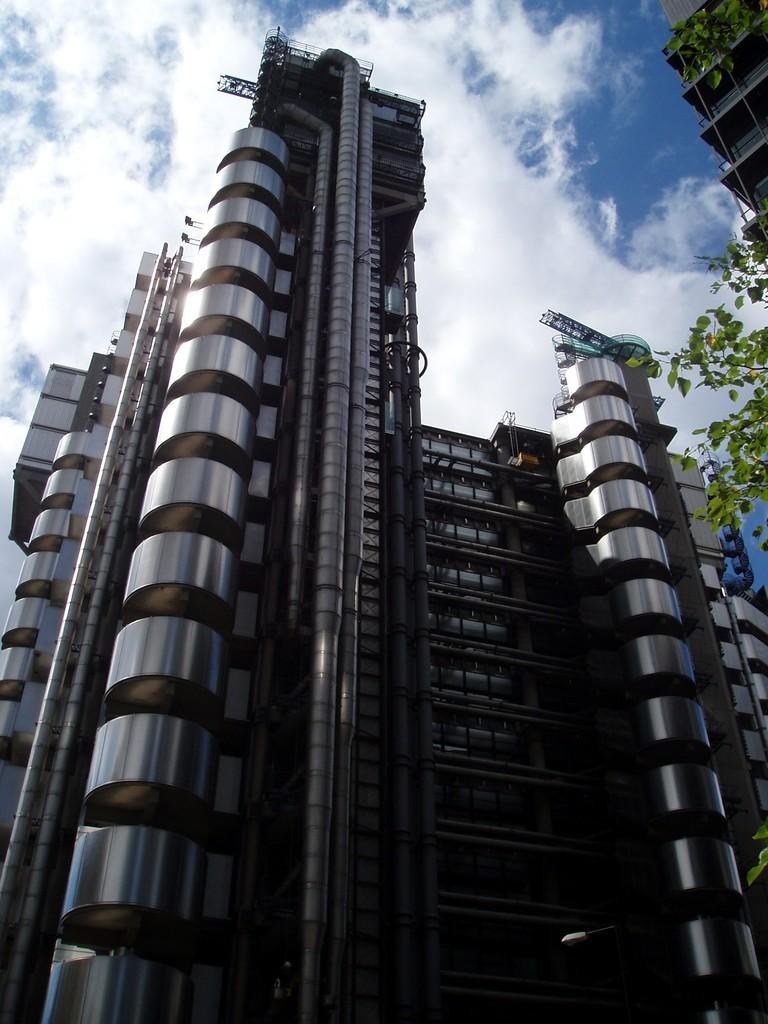Please provide a concise description of this image. In this image, we can see buildings and trees. At the top, there is sky. 